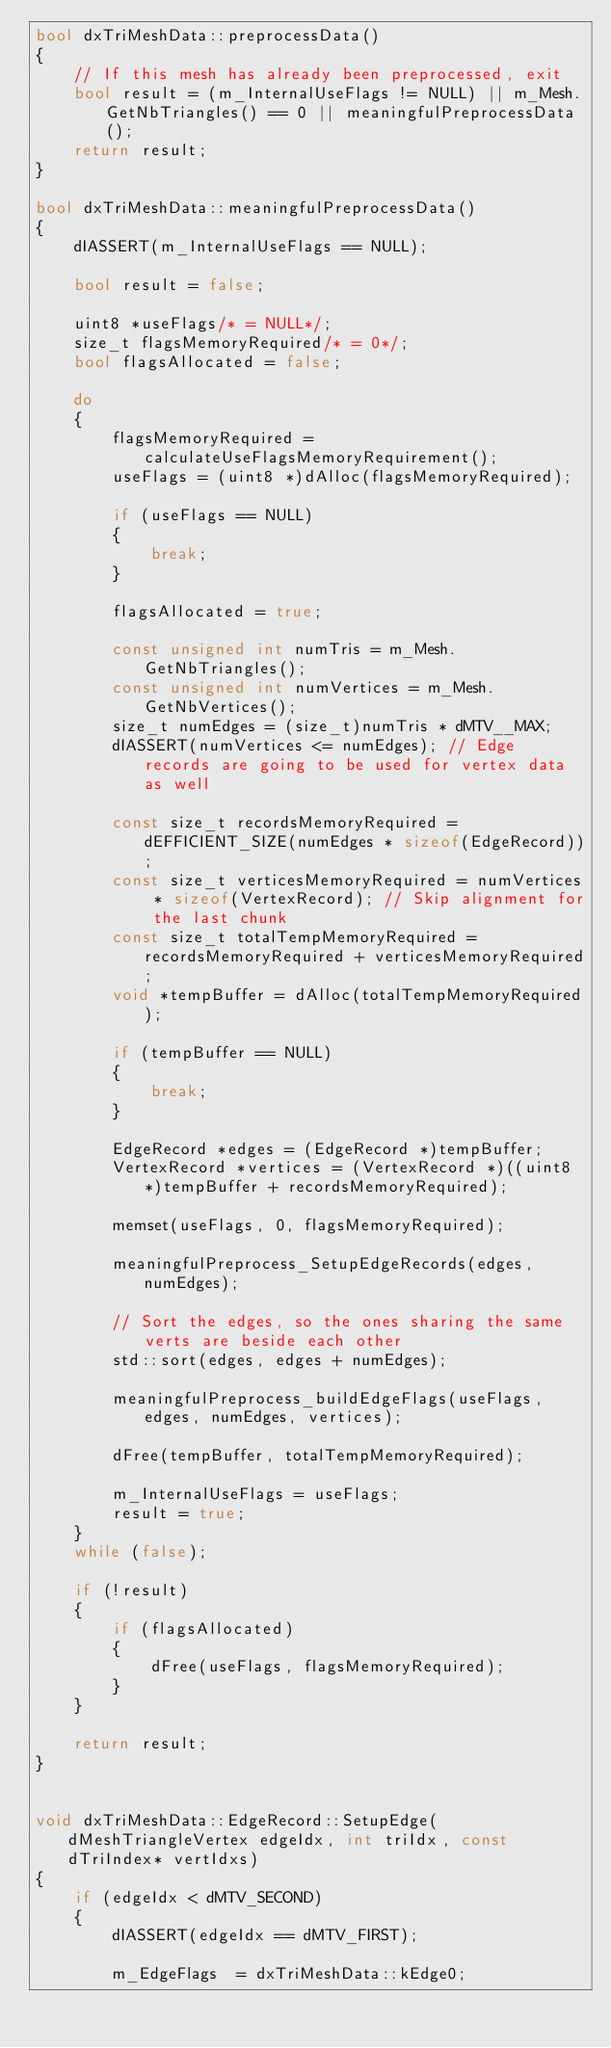<code> <loc_0><loc_0><loc_500><loc_500><_C++_>bool dxTriMeshData::preprocessData()
{
    // If this mesh has already been preprocessed, exit
    bool result = (m_InternalUseFlags != NULL) || m_Mesh.GetNbTriangles() == 0 || meaningfulPreprocessData();
    return result;
}

bool dxTriMeshData::meaningfulPreprocessData()
{
    dIASSERT(m_InternalUseFlags == NULL);

    bool result = false;

    uint8 *useFlags/* = NULL*/;
    size_t flagsMemoryRequired/* = 0*/;
    bool flagsAllocated = false;

    do 
    {
        flagsMemoryRequired = calculateUseFlagsMemoryRequirement();
        useFlags = (uint8 *)dAlloc(flagsMemoryRequired);

        if (useFlags == NULL)
        {
            break;
        }

        flagsAllocated = true;

        const unsigned int numTris = m_Mesh.GetNbTriangles();
        const unsigned int numVertices = m_Mesh.GetNbVertices();
        size_t numEdges = (size_t)numTris * dMTV__MAX;
        dIASSERT(numVertices <= numEdges); // Edge records are going to be used for vertex data as well

        const size_t recordsMemoryRequired = dEFFICIENT_SIZE(numEdges * sizeof(EdgeRecord));
        const size_t verticesMemoryRequired = numVertices * sizeof(VertexRecord); // Skip alignment for the last chunk
        const size_t totalTempMemoryRequired = recordsMemoryRequired + verticesMemoryRequired;
        void *tempBuffer = dAlloc(totalTempMemoryRequired);
        
        if (tempBuffer == NULL)
        {
            break;
        }

        EdgeRecord *edges = (EdgeRecord *)tempBuffer;
        VertexRecord *vertices = (VertexRecord *)((uint8 *)tempBuffer + recordsMemoryRequired);

        memset(useFlags, 0, flagsMemoryRequired);

        meaningfulPreprocess_SetupEdgeRecords(edges, numEdges);

        // Sort the edges, so the ones sharing the same verts are beside each other
        std::sort(edges, edges + numEdges);

        meaningfulPreprocess_buildEdgeFlags(useFlags, edges, numEdges, vertices);

        dFree(tempBuffer, totalTempMemoryRequired);
    	
        m_InternalUseFlags = useFlags;
        result = true;
    }
    while (false);

    if (!result)
    {
        if (flagsAllocated)
        {
            dFree(useFlags, flagsMemoryRequired);
        }
    }

    return result;
}


void dxTriMeshData::EdgeRecord::SetupEdge(dMeshTriangleVertex edgeIdx, int triIdx, const dTriIndex* vertIdxs)
{
    if (edgeIdx < dMTV_SECOND)
    {
        dIASSERT(edgeIdx == dMTV_FIRST);

        m_EdgeFlags  = dxTriMeshData::kEdge0;</code> 